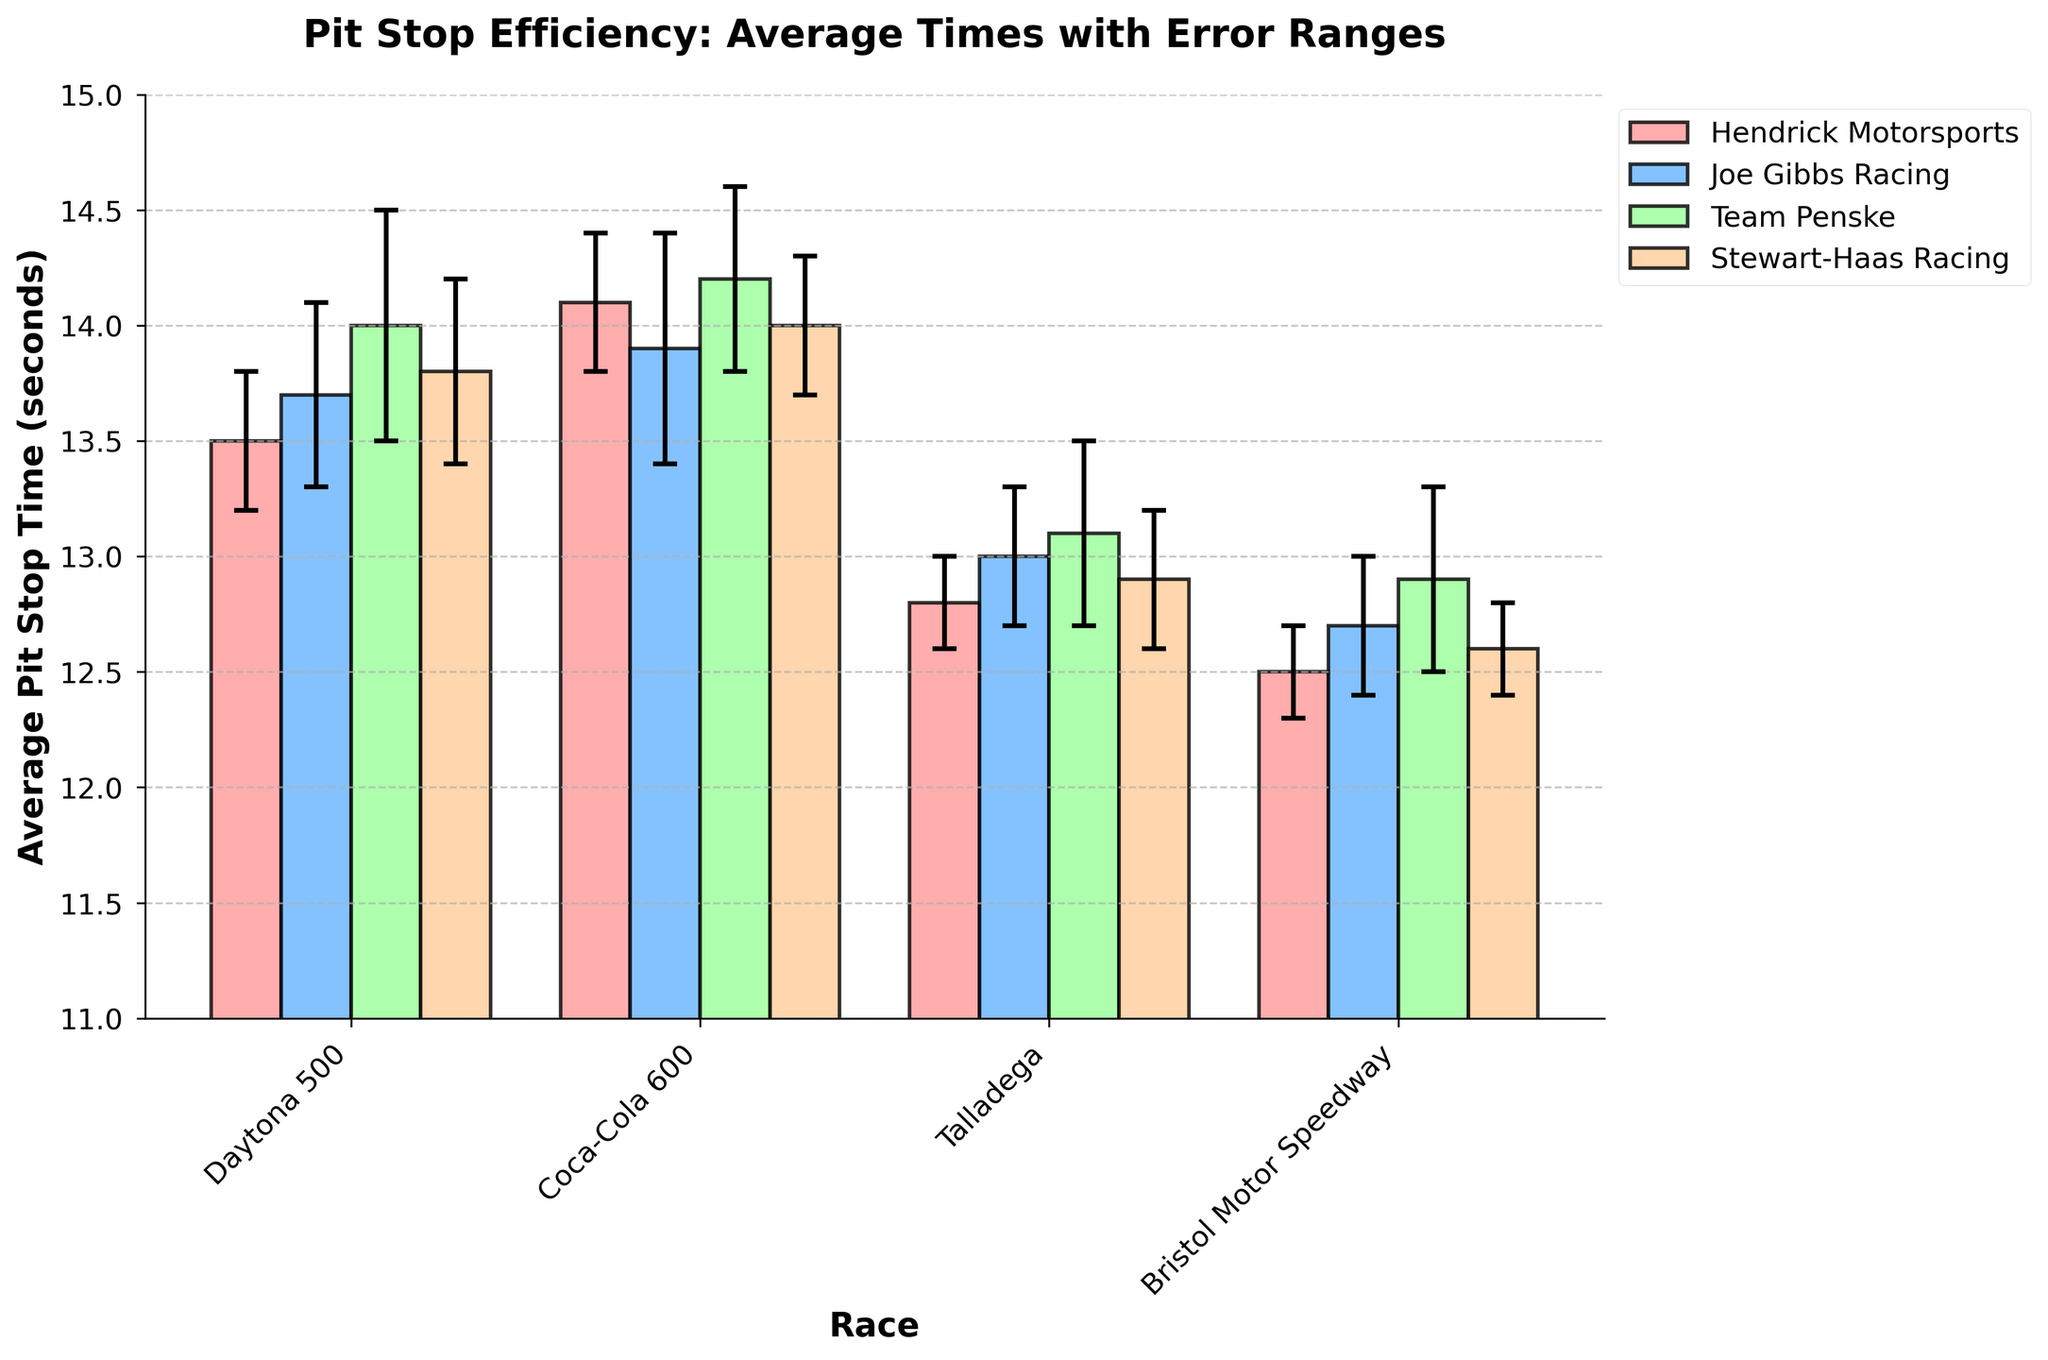Which race has the shortest average pit stop time for Hendrick Motorsports? Look at the bar heights for Hendrick Motorsports across all races. The shortest bar corresponds to the race with the shortest average pit stop time.
Answer: Bristol Motor Speedway What is the average pit stop time for Team Penske during the Daytona 500 and Bristol Motor Speedway? Identify the average pit stop times for Team Penske in both races and then calculate the average: (14.0 + 12.9) / 2 = 13.45 seconds.
Answer: 13.45 seconds Between Joe Gibbs Racing and Stewart-Haas Racing, which team had a lower average pit stop time in the Coca-Cola 600? Compare the average pit stop times for Joe Gibbs Racing and Stewart-Haas Racing in the Coca-Cola 600. The lower value indicates the team with the lower average pit stop time.
Answer: Joe Gibbs Racing Which team had the greatest variation in pit stop times in the Daytona 500? The team with the largest error bar in the figure indicates the greatest variation.
Answer: Team Penske How do average pit stop times for Team Penske compare across Daytona 500 and Talladega? Find the average pit stop times for Team Penske in both races. Daytona 500 is 14.0 seconds, and Talladega is 13.1 seconds. Compare these values to determine which is higher or lower.
Answer: Taller (higher) in Daytona 500 What is the total number of teams depicted in the figure? Count the number of different teams listed in the legend or color bars.
Answer: 4 teams Among all teams, which one had the smallest error range in any race, and what was that value? Look at the error bars across all teams and races. Identify the smallest value.
Answer: Hendrick Motorsports at Talladega with 0.2 seconds Which race shows the greatest overall variation in average pit stop times? Compare the spread of error bars for all teams within each race. The race with the widest range among the error bars indicates the greatest overall variation.
Answer: Daytona 500 Considering all races, which team had the most consistent pit stop times, and how can you tell? The team with the smallest and most uniform error bars across all races indicates the most consistent pit stop times.
Answer: Hendrick Motorsports 